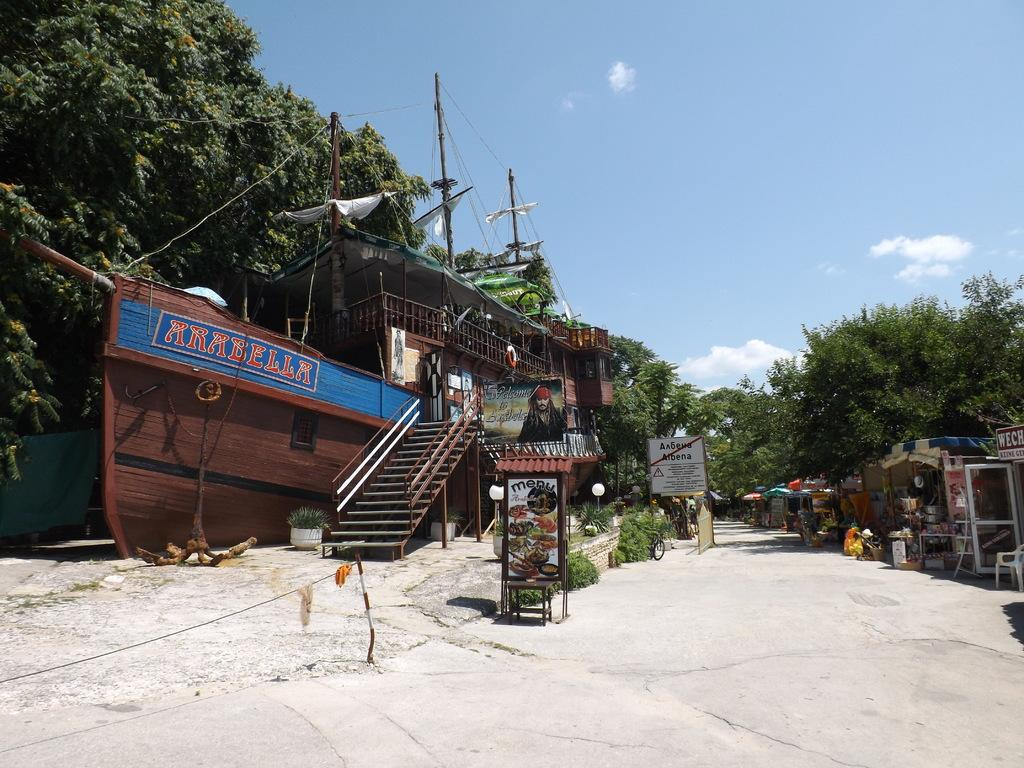What is the main feature of the image? There is a road in the image. What can be found beside the road? There are stalls beside the road. What can be seen in the background of the image? There are trees and electric poles with cables in the background of the image. What type of blade is being used to cut the trees in the image? There is no blade or tree-cutting activity depicted in the image. 